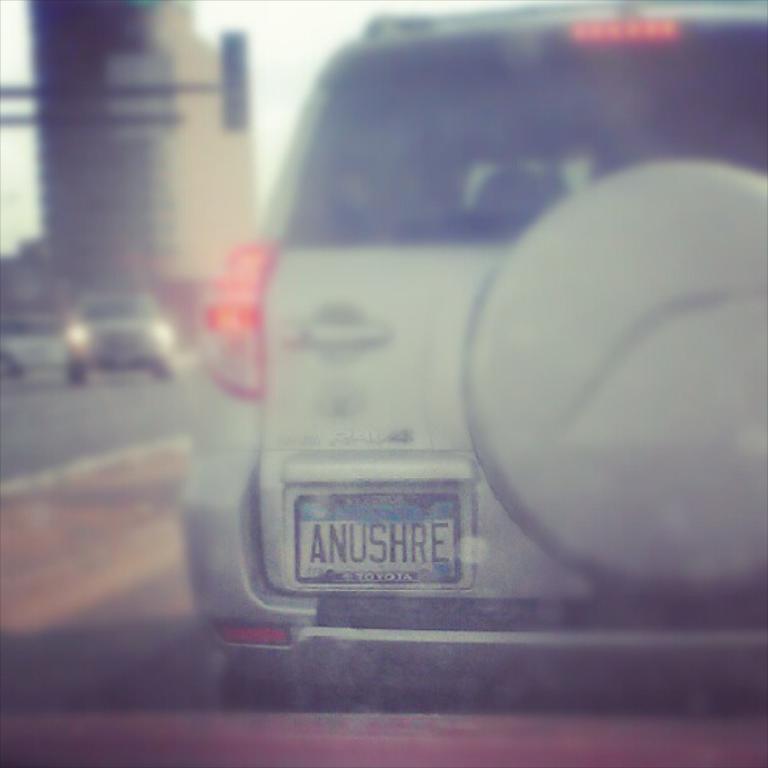What is the brand of car?
Ensure brevity in your answer.  Toyota. 